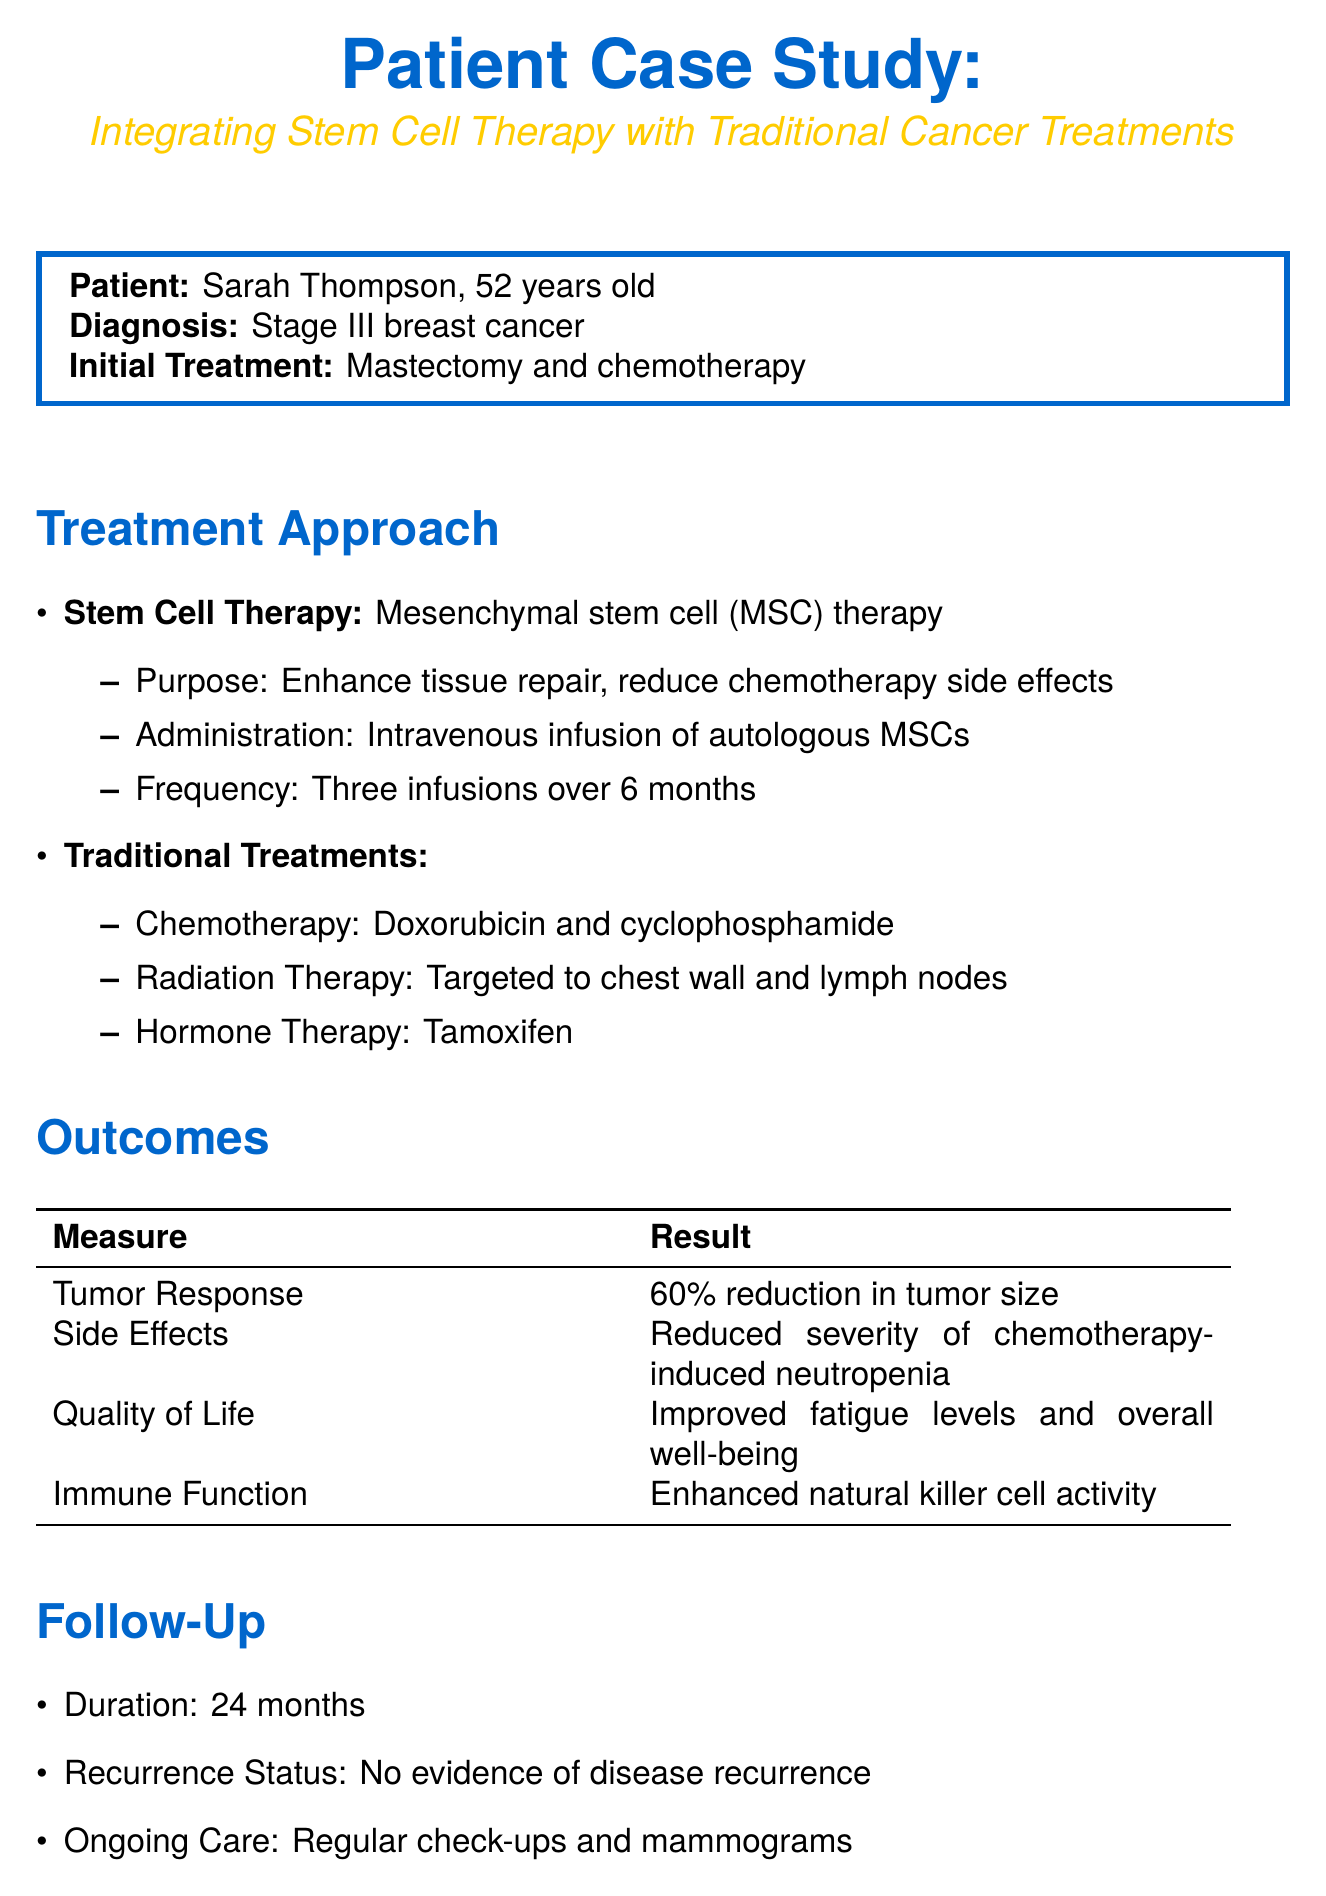What is the name of the patient? The patient's name is listed in the document under patient information.
Answer: Sarah Thompson What is the age of the patient? The document specifies the patient's age in the patient info section.
Answer: 52 What type of stem cell therapy was used? The document describes the type of stem cell therapy integrated into the treatment.
Answer: Mesenchymal stem cell (MSC) therapy How many infusions of MSCs were administered? The frequency of MSC infusions is detailed in the stem cell therapy section.
Answer: Three infusions What was the reduction in tumor size? The tumor response outcome includes specific statistics regarding tumor size reduction.
Answer: 60% reduction What was the effect on chemotherapy-induced neutropenia? The outcomes section explains the results related to side effects experienced by the patient.
Answer: Reduced severity What was the recurrence status after follow-up? The follow-up section indicates the patient's status regarding disease recurrence.
Answer: No evidence of disease recurrence Describe one potential mechanism of MSC therapy mentioned in the document. The discussion section provides insights into how MSCs may affect the tumor microenvironment.
Answer: Modulate the tumor microenvironment What limitation is noted in the discussion? Limitations are specified within the discussion, reflecting on the study's scope.
Answer: Small sample size What future direction is suggested for the treatment approach? The document outlines future directions for research and treatment in the discussion section.
Answer: Exploring combination with immunotherapy 